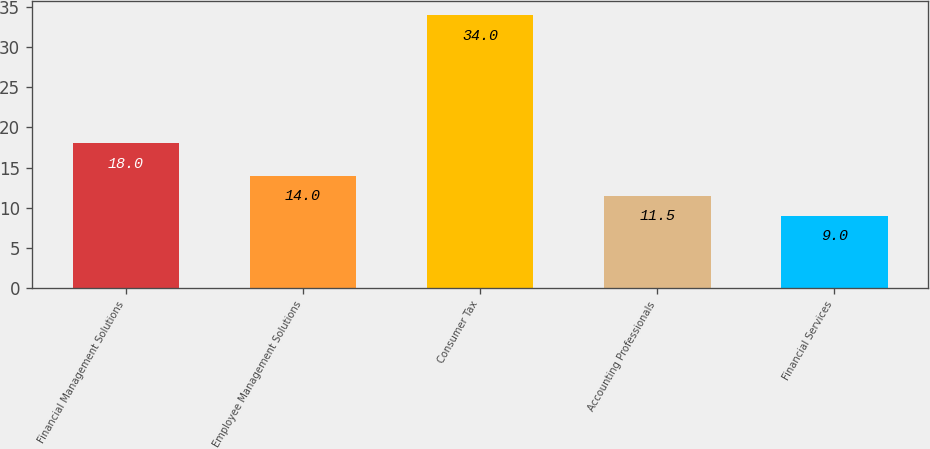Convert chart to OTSL. <chart><loc_0><loc_0><loc_500><loc_500><bar_chart><fcel>Financial Management Solutions<fcel>Employee Management Solutions<fcel>Consumer Tax<fcel>Accounting Professionals<fcel>Financial Services<nl><fcel>18<fcel>14<fcel>34<fcel>11.5<fcel>9<nl></chart> 